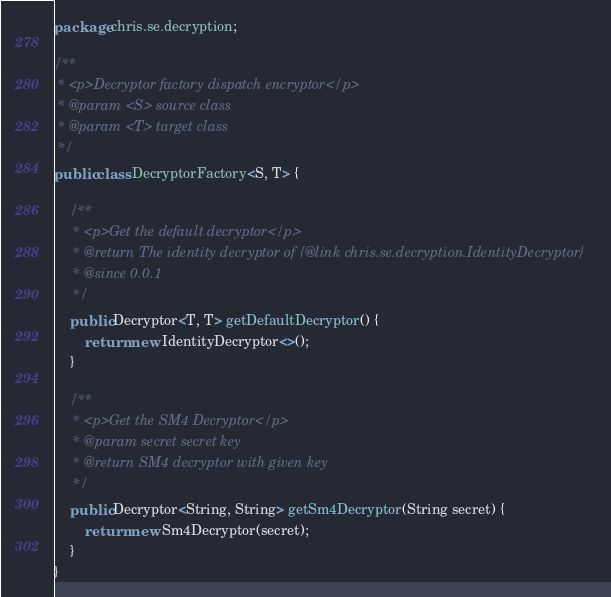<code> <loc_0><loc_0><loc_500><loc_500><_Java_>package chris.se.decryption;

/**
 * <p>Decryptor factory dispatch encryptor</p>
 * @param <S> source class
 * @param <T> target class
 */
public class DecryptorFactory<S, T> {

    /**
     * <p>Get the default decryptor</p>
     * @return The identity decryptor of {@link chris.se.decryption.IdentityDecryptor}
     * @since 0.0.1
     */
    public Decryptor<T, T> getDefaultDecryptor() {
        return new IdentityDecryptor<>();
    }

    /**
     * <p>Get the SM4 Decryptor</p>
     * @param secret secret key
     * @return SM4 decryptor with given key
     */
    public Decryptor<String, String> getSm4Decryptor(String secret) {
        return new Sm4Decryptor(secret);
    }
}
</code> 